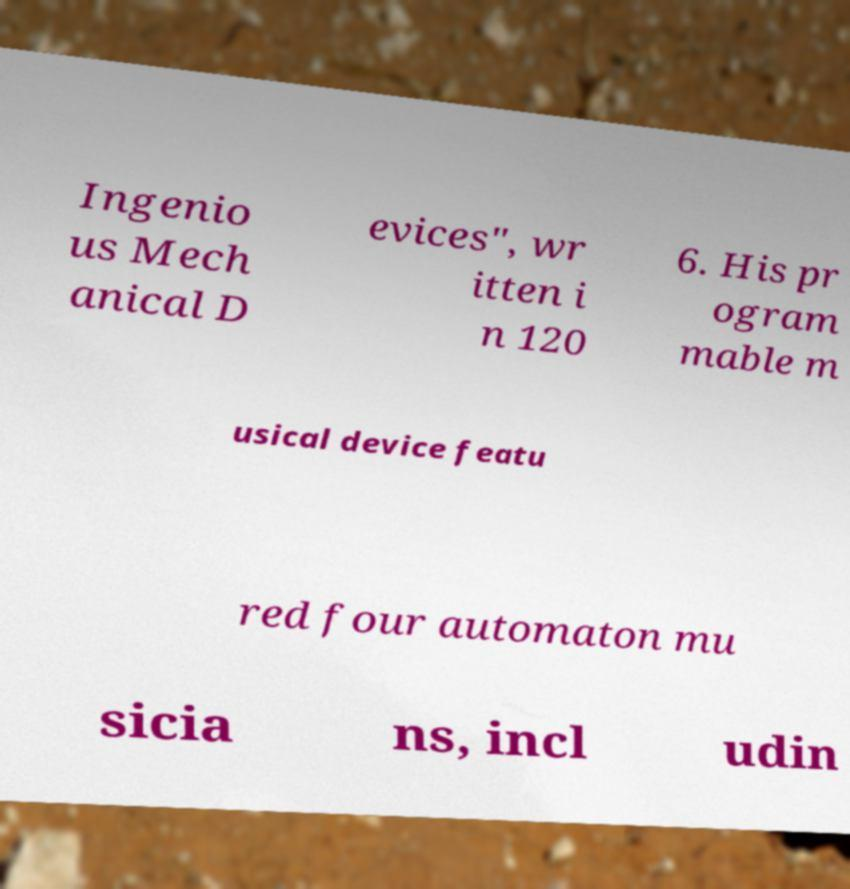Please identify and transcribe the text found in this image. Ingenio us Mech anical D evices", wr itten i n 120 6. His pr ogram mable m usical device featu red four automaton mu sicia ns, incl udin 